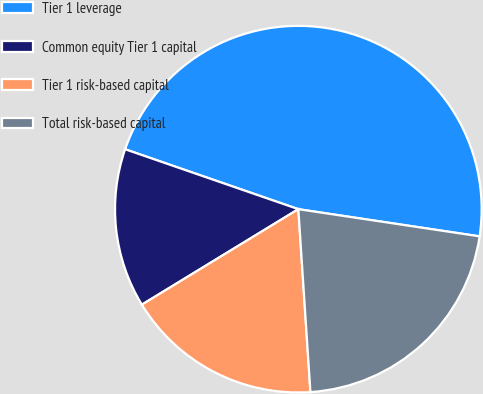Convert chart to OTSL. <chart><loc_0><loc_0><loc_500><loc_500><pie_chart><fcel>Tier 1 leverage<fcel>Common equity Tier 1 capital<fcel>Tier 1 risk-based capital<fcel>Total risk-based capital<nl><fcel>47.07%<fcel>14.02%<fcel>17.33%<fcel>21.58%<nl></chart> 